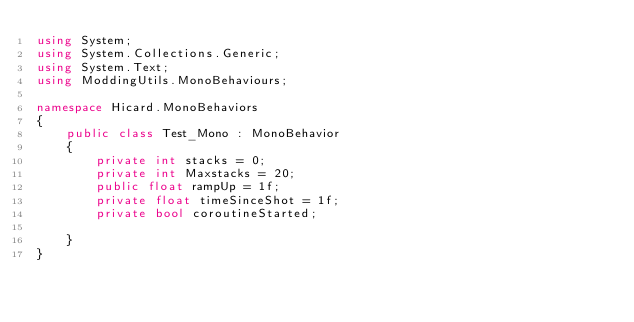<code> <loc_0><loc_0><loc_500><loc_500><_C#_>using System;
using System.Collections.Generic;
using System.Text;
using ModdingUtils.MonoBehaviours;

namespace Hicard.MonoBehaviors
{
    public class Test_Mono : MonoBehavior
    {
        private int stacks = 0;
        private int Maxstacks = 20;
        public float rampUp = 1f;
        private float timeSinceShot = 1f;
        private bool coroutineStarted;

    }
}
</code> 